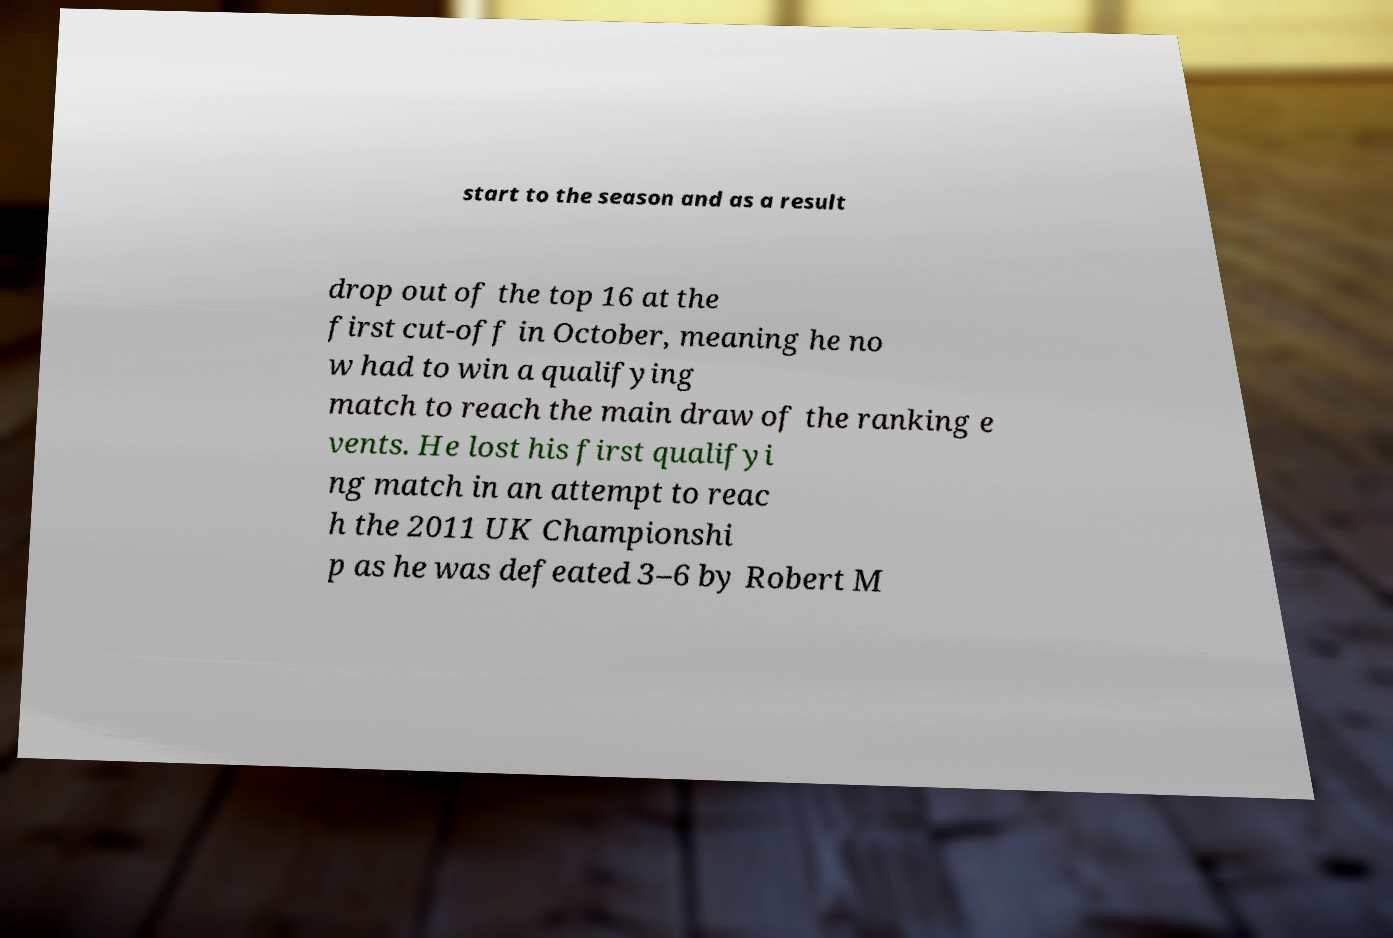There's text embedded in this image that I need extracted. Can you transcribe it verbatim? start to the season and as a result drop out of the top 16 at the first cut-off in October, meaning he no w had to win a qualifying match to reach the main draw of the ranking e vents. He lost his first qualifyi ng match in an attempt to reac h the 2011 UK Championshi p as he was defeated 3–6 by Robert M 